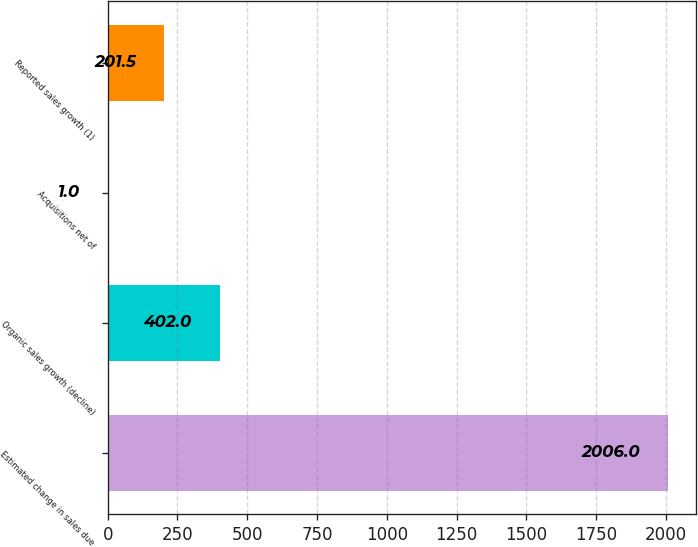<chart> <loc_0><loc_0><loc_500><loc_500><bar_chart><fcel>Estimated change in sales due<fcel>Organic sales growth (decline)<fcel>Acquisitions net of<fcel>Reported sales growth (1)<nl><fcel>2006<fcel>402<fcel>1<fcel>201.5<nl></chart> 